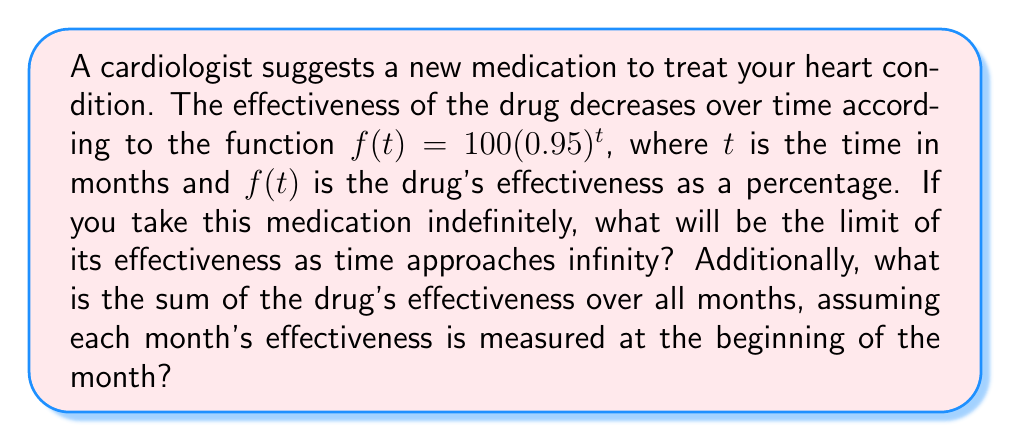What is the answer to this math problem? To solve this problem, we'll use limits and geometric series:

1. Limit of effectiveness as time approaches infinity:
   $$\lim_{t \to \infty} f(t) = \lim_{t \to \infty} 100(0.95)^t$$
   Since $0 < 0.95 < 1$, as $t$ approaches infinity, $(0.95)^t$ approaches 0.
   Therefore, $\lim_{t \to \infty} f(t) = 100 \cdot 0 = 0$

2. Sum of effectiveness over all months:
   This forms a geometric series with first term $a = 100$ and common ratio $r = 0.95$.
   The sum of an infinite geometric series with $|r| < 1$ is given by $S_{\infty} = \frac{a}{1-r}$

   $$S_{\infty} = \frac{100}{1-0.95} = \frac{100}{0.05} = 2000$$

Thus, the sum of the drug's effectiveness over all months is 2000 percentage-months.
Answer: Limit of effectiveness: 0%. Sum of effectiveness: 2000 percentage-months. 